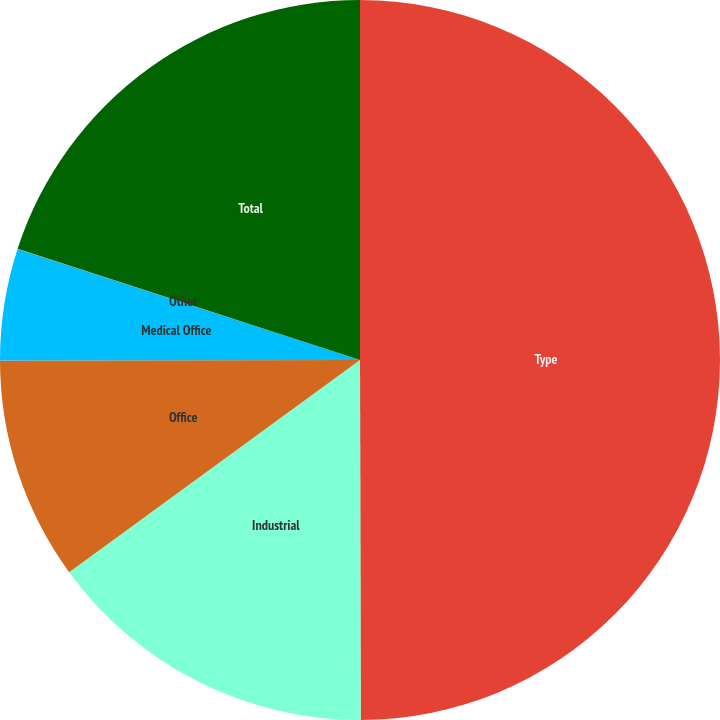Convert chart to OTSL. <chart><loc_0><loc_0><loc_500><loc_500><pie_chart><fcel>Type<fcel>Industrial<fcel>Office<fcel>Medical Office<fcel>Other<fcel>Total<nl><fcel>49.97%<fcel>15.0%<fcel>10.01%<fcel>5.01%<fcel>0.01%<fcel>20.0%<nl></chart> 